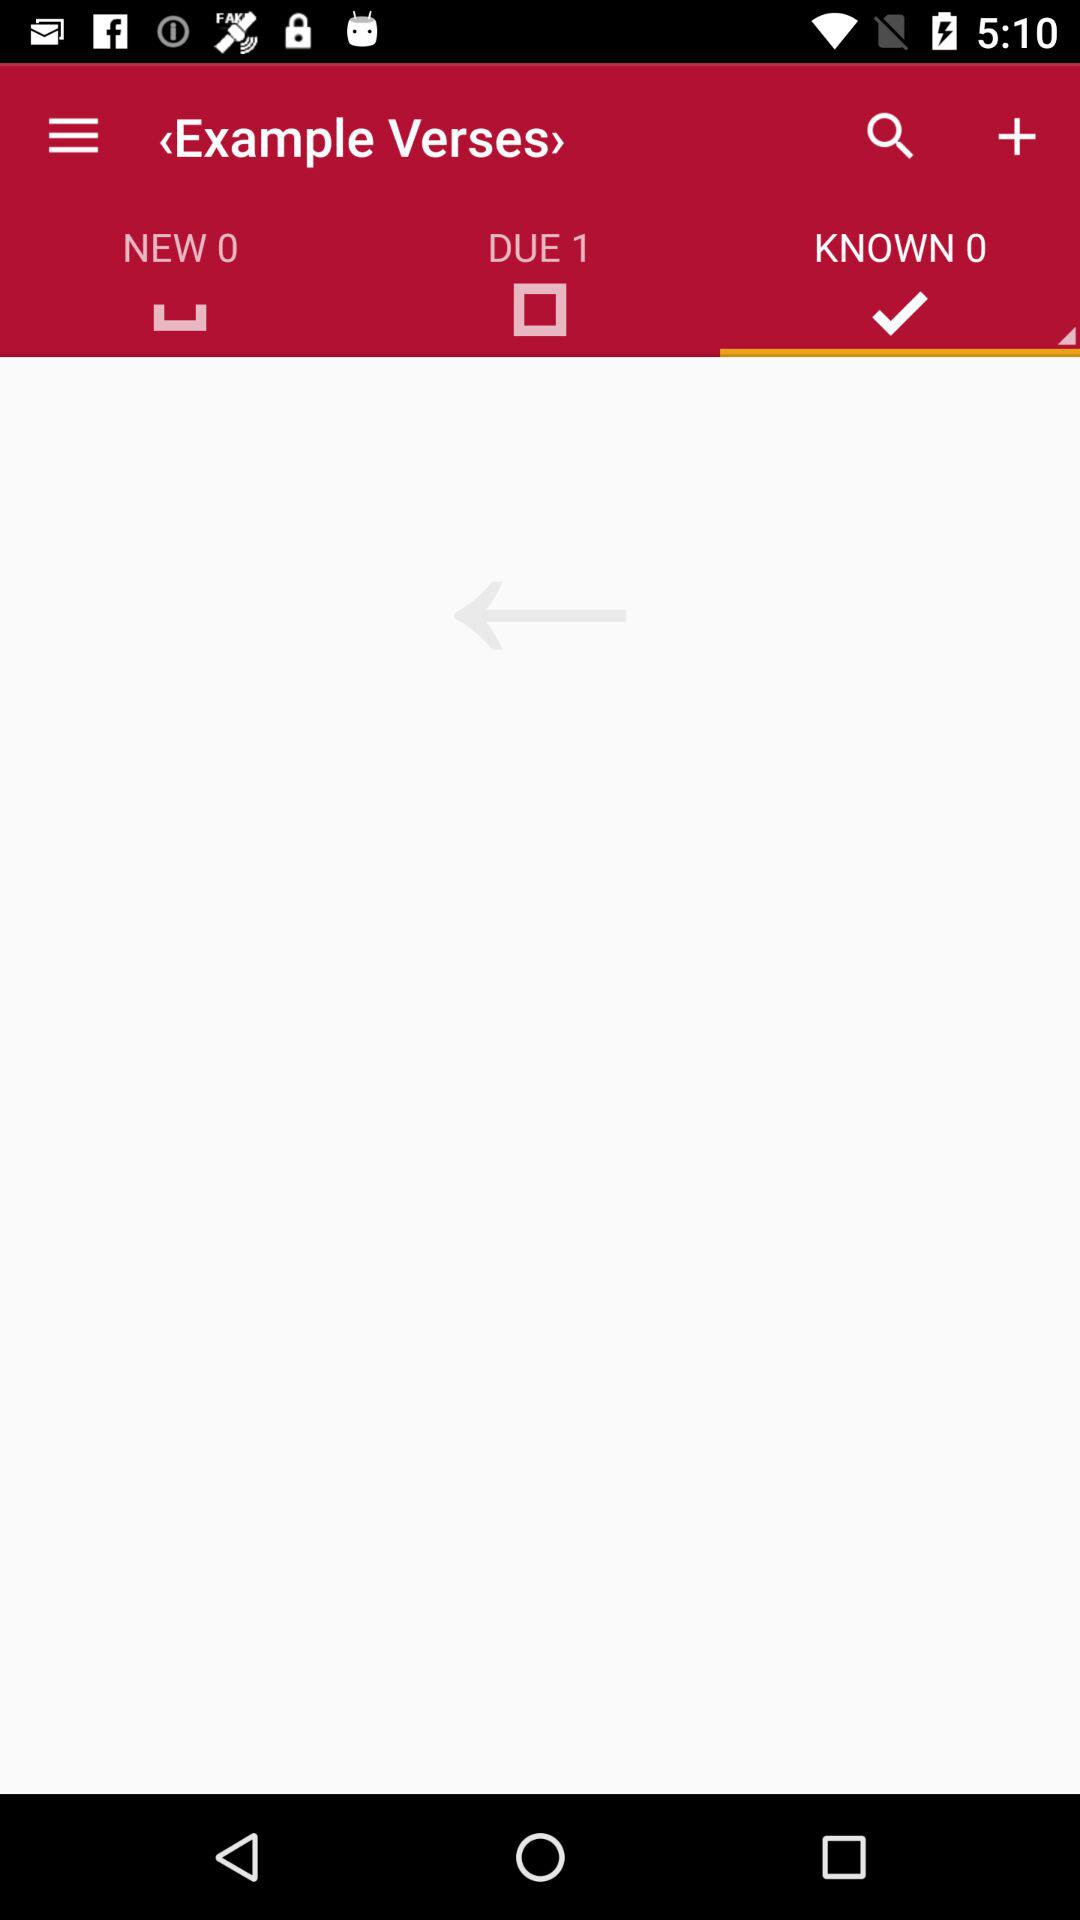Which tab is selected? The selected tab is "KNOWN 0". 